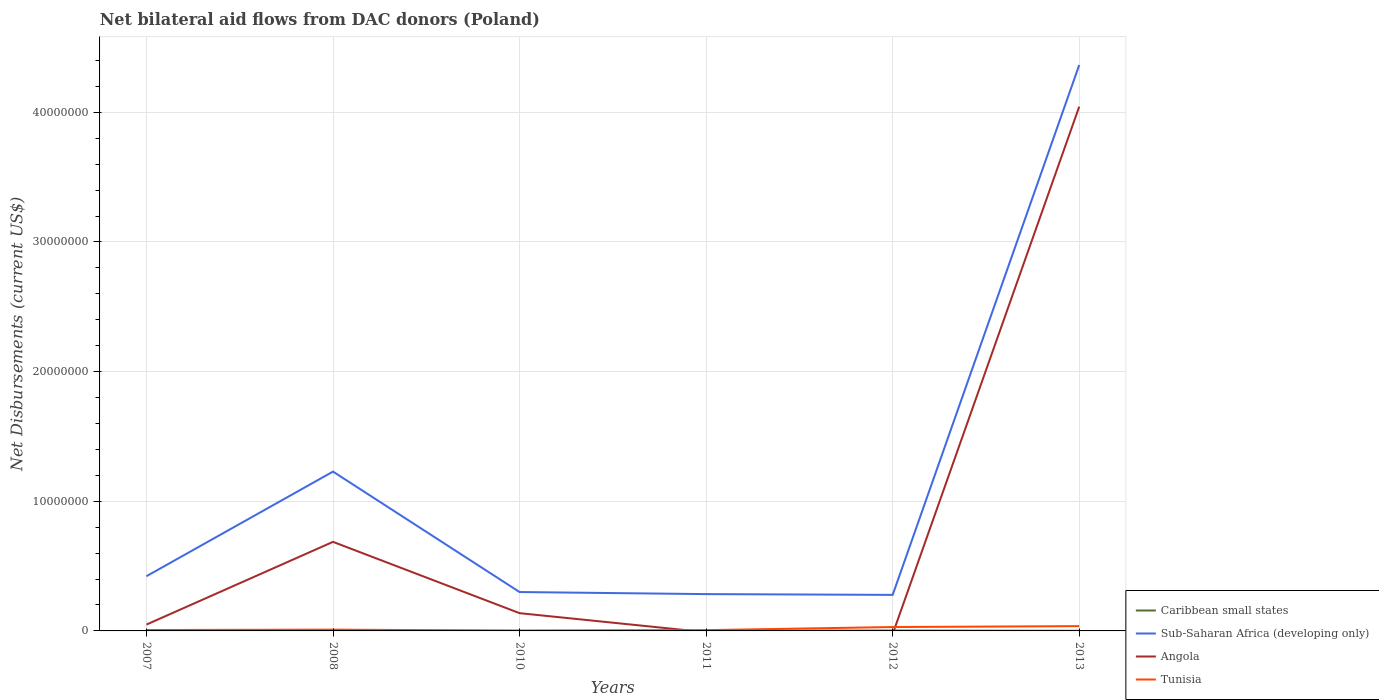Does the line corresponding to Caribbean small states intersect with the line corresponding to Sub-Saharan Africa (developing only)?
Your response must be concise. No. Is the number of lines equal to the number of legend labels?
Provide a short and direct response. No. What is the difference between the highest and the second highest net bilateral aid flows in Angola?
Ensure brevity in your answer.  4.04e+07. Is the net bilateral aid flows in Angola strictly greater than the net bilateral aid flows in Tunisia over the years?
Offer a terse response. No. How many lines are there?
Your response must be concise. 4. Are the values on the major ticks of Y-axis written in scientific E-notation?
Provide a succinct answer. No. Does the graph contain any zero values?
Give a very brief answer. Yes. Does the graph contain grids?
Make the answer very short. Yes. How are the legend labels stacked?
Ensure brevity in your answer.  Vertical. What is the title of the graph?
Offer a very short reply. Net bilateral aid flows from DAC donors (Poland). Does "Japan" appear as one of the legend labels in the graph?
Your answer should be compact. No. What is the label or title of the Y-axis?
Offer a terse response. Net Disbursements (current US$). What is the Net Disbursements (current US$) in Caribbean small states in 2007?
Your response must be concise. 7.00e+04. What is the Net Disbursements (current US$) in Sub-Saharan Africa (developing only) in 2007?
Make the answer very short. 4.22e+06. What is the Net Disbursements (current US$) in Angola in 2007?
Ensure brevity in your answer.  4.90e+05. What is the Net Disbursements (current US$) in Tunisia in 2007?
Your response must be concise. 7.00e+04. What is the Net Disbursements (current US$) in Caribbean small states in 2008?
Keep it short and to the point. 3.00e+04. What is the Net Disbursements (current US$) of Sub-Saharan Africa (developing only) in 2008?
Provide a succinct answer. 1.23e+07. What is the Net Disbursements (current US$) of Angola in 2008?
Give a very brief answer. 6.87e+06. What is the Net Disbursements (current US$) of Caribbean small states in 2010?
Keep it short and to the point. 10000. What is the Net Disbursements (current US$) in Sub-Saharan Africa (developing only) in 2010?
Your answer should be compact. 3.00e+06. What is the Net Disbursements (current US$) in Angola in 2010?
Make the answer very short. 1.37e+06. What is the Net Disbursements (current US$) in Caribbean small states in 2011?
Your response must be concise. 2.00e+04. What is the Net Disbursements (current US$) in Sub-Saharan Africa (developing only) in 2011?
Provide a succinct answer. 2.84e+06. What is the Net Disbursements (current US$) of Tunisia in 2011?
Your answer should be very brief. 6.00e+04. What is the Net Disbursements (current US$) in Caribbean small states in 2012?
Your answer should be compact. 3.00e+04. What is the Net Disbursements (current US$) of Sub-Saharan Africa (developing only) in 2012?
Your answer should be very brief. 2.78e+06. What is the Net Disbursements (current US$) of Sub-Saharan Africa (developing only) in 2013?
Ensure brevity in your answer.  4.36e+07. What is the Net Disbursements (current US$) of Angola in 2013?
Keep it short and to the point. 4.04e+07. What is the Net Disbursements (current US$) of Tunisia in 2013?
Ensure brevity in your answer.  3.70e+05. Across all years, what is the maximum Net Disbursements (current US$) in Caribbean small states?
Offer a very short reply. 7.00e+04. Across all years, what is the maximum Net Disbursements (current US$) of Sub-Saharan Africa (developing only)?
Your answer should be very brief. 4.36e+07. Across all years, what is the maximum Net Disbursements (current US$) of Angola?
Give a very brief answer. 4.04e+07. Across all years, what is the maximum Net Disbursements (current US$) in Tunisia?
Your response must be concise. 3.70e+05. Across all years, what is the minimum Net Disbursements (current US$) in Caribbean small states?
Your response must be concise. 10000. Across all years, what is the minimum Net Disbursements (current US$) of Sub-Saharan Africa (developing only)?
Ensure brevity in your answer.  2.78e+06. Across all years, what is the minimum Net Disbursements (current US$) of Angola?
Your answer should be very brief. 0. What is the total Net Disbursements (current US$) of Caribbean small states in the graph?
Provide a short and direct response. 1.70e+05. What is the total Net Disbursements (current US$) in Sub-Saharan Africa (developing only) in the graph?
Keep it short and to the point. 6.88e+07. What is the total Net Disbursements (current US$) of Angola in the graph?
Make the answer very short. 4.92e+07. What is the total Net Disbursements (current US$) in Tunisia in the graph?
Offer a very short reply. 9.20e+05. What is the difference between the Net Disbursements (current US$) of Caribbean small states in 2007 and that in 2008?
Your response must be concise. 4.00e+04. What is the difference between the Net Disbursements (current US$) in Sub-Saharan Africa (developing only) in 2007 and that in 2008?
Make the answer very short. -8.07e+06. What is the difference between the Net Disbursements (current US$) in Angola in 2007 and that in 2008?
Offer a very short reply. -6.38e+06. What is the difference between the Net Disbursements (current US$) of Tunisia in 2007 and that in 2008?
Give a very brief answer. -3.00e+04. What is the difference between the Net Disbursements (current US$) in Sub-Saharan Africa (developing only) in 2007 and that in 2010?
Offer a terse response. 1.22e+06. What is the difference between the Net Disbursements (current US$) in Angola in 2007 and that in 2010?
Your answer should be very brief. -8.80e+05. What is the difference between the Net Disbursements (current US$) in Sub-Saharan Africa (developing only) in 2007 and that in 2011?
Give a very brief answer. 1.38e+06. What is the difference between the Net Disbursements (current US$) in Caribbean small states in 2007 and that in 2012?
Offer a terse response. 4.00e+04. What is the difference between the Net Disbursements (current US$) of Sub-Saharan Africa (developing only) in 2007 and that in 2012?
Your response must be concise. 1.44e+06. What is the difference between the Net Disbursements (current US$) in Sub-Saharan Africa (developing only) in 2007 and that in 2013?
Your answer should be compact. -3.94e+07. What is the difference between the Net Disbursements (current US$) of Angola in 2007 and that in 2013?
Your response must be concise. -4.00e+07. What is the difference between the Net Disbursements (current US$) in Sub-Saharan Africa (developing only) in 2008 and that in 2010?
Make the answer very short. 9.29e+06. What is the difference between the Net Disbursements (current US$) in Angola in 2008 and that in 2010?
Keep it short and to the point. 5.50e+06. What is the difference between the Net Disbursements (current US$) of Caribbean small states in 2008 and that in 2011?
Provide a short and direct response. 10000. What is the difference between the Net Disbursements (current US$) in Sub-Saharan Africa (developing only) in 2008 and that in 2011?
Keep it short and to the point. 9.45e+06. What is the difference between the Net Disbursements (current US$) in Caribbean small states in 2008 and that in 2012?
Ensure brevity in your answer.  0. What is the difference between the Net Disbursements (current US$) in Sub-Saharan Africa (developing only) in 2008 and that in 2012?
Ensure brevity in your answer.  9.51e+06. What is the difference between the Net Disbursements (current US$) in Caribbean small states in 2008 and that in 2013?
Offer a very short reply. 2.00e+04. What is the difference between the Net Disbursements (current US$) of Sub-Saharan Africa (developing only) in 2008 and that in 2013?
Provide a short and direct response. -3.14e+07. What is the difference between the Net Disbursements (current US$) in Angola in 2008 and that in 2013?
Make the answer very short. -3.36e+07. What is the difference between the Net Disbursements (current US$) in Tunisia in 2008 and that in 2013?
Make the answer very short. -2.70e+05. What is the difference between the Net Disbursements (current US$) of Caribbean small states in 2010 and that in 2011?
Give a very brief answer. -10000. What is the difference between the Net Disbursements (current US$) in Sub-Saharan Africa (developing only) in 2010 and that in 2011?
Offer a terse response. 1.60e+05. What is the difference between the Net Disbursements (current US$) in Tunisia in 2010 and that in 2011?
Offer a very short reply. -4.00e+04. What is the difference between the Net Disbursements (current US$) of Tunisia in 2010 and that in 2012?
Your answer should be very brief. -2.80e+05. What is the difference between the Net Disbursements (current US$) of Sub-Saharan Africa (developing only) in 2010 and that in 2013?
Offer a very short reply. -4.06e+07. What is the difference between the Net Disbursements (current US$) of Angola in 2010 and that in 2013?
Ensure brevity in your answer.  -3.91e+07. What is the difference between the Net Disbursements (current US$) in Tunisia in 2010 and that in 2013?
Provide a short and direct response. -3.50e+05. What is the difference between the Net Disbursements (current US$) of Caribbean small states in 2011 and that in 2012?
Your response must be concise. -10000. What is the difference between the Net Disbursements (current US$) in Sub-Saharan Africa (developing only) in 2011 and that in 2012?
Provide a short and direct response. 6.00e+04. What is the difference between the Net Disbursements (current US$) in Caribbean small states in 2011 and that in 2013?
Make the answer very short. 10000. What is the difference between the Net Disbursements (current US$) of Sub-Saharan Africa (developing only) in 2011 and that in 2013?
Your response must be concise. -4.08e+07. What is the difference between the Net Disbursements (current US$) of Tunisia in 2011 and that in 2013?
Your answer should be compact. -3.10e+05. What is the difference between the Net Disbursements (current US$) of Sub-Saharan Africa (developing only) in 2012 and that in 2013?
Provide a succinct answer. -4.09e+07. What is the difference between the Net Disbursements (current US$) in Tunisia in 2012 and that in 2013?
Offer a very short reply. -7.00e+04. What is the difference between the Net Disbursements (current US$) in Caribbean small states in 2007 and the Net Disbursements (current US$) in Sub-Saharan Africa (developing only) in 2008?
Provide a succinct answer. -1.22e+07. What is the difference between the Net Disbursements (current US$) of Caribbean small states in 2007 and the Net Disbursements (current US$) of Angola in 2008?
Keep it short and to the point. -6.80e+06. What is the difference between the Net Disbursements (current US$) of Caribbean small states in 2007 and the Net Disbursements (current US$) of Tunisia in 2008?
Your answer should be compact. -3.00e+04. What is the difference between the Net Disbursements (current US$) of Sub-Saharan Africa (developing only) in 2007 and the Net Disbursements (current US$) of Angola in 2008?
Make the answer very short. -2.65e+06. What is the difference between the Net Disbursements (current US$) of Sub-Saharan Africa (developing only) in 2007 and the Net Disbursements (current US$) of Tunisia in 2008?
Keep it short and to the point. 4.12e+06. What is the difference between the Net Disbursements (current US$) in Caribbean small states in 2007 and the Net Disbursements (current US$) in Sub-Saharan Africa (developing only) in 2010?
Provide a succinct answer. -2.93e+06. What is the difference between the Net Disbursements (current US$) in Caribbean small states in 2007 and the Net Disbursements (current US$) in Angola in 2010?
Your answer should be very brief. -1.30e+06. What is the difference between the Net Disbursements (current US$) in Sub-Saharan Africa (developing only) in 2007 and the Net Disbursements (current US$) in Angola in 2010?
Your answer should be compact. 2.85e+06. What is the difference between the Net Disbursements (current US$) of Sub-Saharan Africa (developing only) in 2007 and the Net Disbursements (current US$) of Tunisia in 2010?
Your answer should be very brief. 4.20e+06. What is the difference between the Net Disbursements (current US$) in Caribbean small states in 2007 and the Net Disbursements (current US$) in Sub-Saharan Africa (developing only) in 2011?
Your answer should be very brief. -2.77e+06. What is the difference between the Net Disbursements (current US$) in Sub-Saharan Africa (developing only) in 2007 and the Net Disbursements (current US$) in Tunisia in 2011?
Ensure brevity in your answer.  4.16e+06. What is the difference between the Net Disbursements (current US$) in Caribbean small states in 2007 and the Net Disbursements (current US$) in Sub-Saharan Africa (developing only) in 2012?
Provide a succinct answer. -2.71e+06. What is the difference between the Net Disbursements (current US$) in Sub-Saharan Africa (developing only) in 2007 and the Net Disbursements (current US$) in Tunisia in 2012?
Offer a terse response. 3.92e+06. What is the difference between the Net Disbursements (current US$) in Caribbean small states in 2007 and the Net Disbursements (current US$) in Sub-Saharan Africa (developing only) in 2013?
Offer a very short reply. -4.36e+07. What is the difference between the Net Disbursements (current US$) in Caribbean small states in 2007 and the Net Disbursements (current US$) in Angola in 2013?
Provide a succinct answer. -4.04e+07. What is the difference between the Net Disbursements (current US$) in Sub-Saharan Africa (developing only) in 2007 and the Net Disbursements (current US$) in Angola in 2013?
Provide a short and direct response. -3.62e+07. What is the difference between the Net Disbursements (current US$) in Sub-Saharan Africa (developing only) in 2007 and the Net Disbursements (current US$) in Tunisia in 2013?
Your answer should be very brief. 3.85e+06. What is the difference between the Net Disbursements (current US$) of Caribbean small states in 2008 and the Net Disbursements (current US$) of Sub-Saharan Africa (developing only) in 2010?
Keep it short and to the point. -2.97e+06. What is the difference between the Net Disbursements (current US$) of Caribbean small states in 2008 and the Net Disbursements (current US$) of Angola in 2010?
Offer a very short reply. -1.34e+06. What is the difference between the Net Disbursements (current US$) in Caribbean small states in 2008 and the Net Disbursements (current US$) in Tunisia in 2010?
Give a very brief answer. 10000. What is the difference between the Net Disbursements (current US$) of Sub-Saharan Africa (developing only) in 2008 and the Net Disbursements (current US$) of Angola in 2010?
Offer a very short reply. 1.09e+07. What is the difference between the Net Disbursements (current US$) in Sub-Saharan Africa (developing only) in 2008 and the Net Disbursements (current US$) in Tunisia in 2010?
Your response must be concise. 1.23e+07. What is the difference between the Net Disbursements (current US$) in Angola in 2008 and the Net Disbursements (current US$) in Tunisia in 2010?
Your response must be concise. 6.85e+06. What is the difference between the Net Disbursements (current US$) in Caribbean small states in 2008 and the Net Disbursements (current US$) in Sub-Saharan Africa (developing only) in 2011?
Provide a succinct answer. -2.81e+06. What is the difference between the Net Disbursements (current US$) in Sub-Saharan Africa (developing only) in 2008 and the Net Disbursements (current US$) in Tunisia in 2011?
Ensure brevity in your answer.  1.22e+07. What is the difference between the Net Disbursements (current US$) in Angola in 2008 and the Net Disbursements (current US$) in Tunisia in 2011?
Ensure brevity in your answer.  6.81e+06. What is the difference between the Net Disbursements (current US$) in Caribbean small states in 2008 and the Net Disbursements (current US$) in Sub-Saharan Africa (developing only) in 2012?
Provide a short and direct response. -2.75e+06. What is the difference between the Net Disbursements (current US$) of Caribbean small states in 2008 and the Net Disbursements (current US$) of Tunisia in 2012?
Give a very brief answer. -2.70e+05. What is the difference between the Net Disbursements (current US$) in Sub-Saharan Africa (developing only) in 2008 and the Net Disbursements (current US$) in Tunisia in 2012?
Your response must be concise. 1.20e+07. What is the difference between the Net Disbursements (current US$) in Angola in 2008 and the Net Disbursements (current US$) in Tunisia in 2012?
Make the answer very short. 6.57e+06. What is the difference between the Net Disbursements (current US$) in Caribbean small states in 2008 and the Net Disbursements (current US$) in Sub-Saharan Africa (developing only) in 2013?
Keep it short and to the point. -4.36e+07. What is the difference between the Net Disbursements (current US$) in Caribbean small states in 2008 and the Net Disbursements (current US$) in Angola in 2013?
Your answer should be compact. -4.04e+07. What is the difference between the Net Disbursements (current US$) in Sub-Saharan Africa (developing only) in 2008 and the Net Disbursements (current US$) in Angola in 2013?
Provide a short and direct response. -2.82e+07. What is the difference between the Net Disbursements (current US$) of Sub-Saharan Africa (developing only) in 2008 and the Net Disbursements (current US$) of Tunisia in 2013?
Give a very brief answer. 1.19e+07. What is the difference between the Net Disbursements (current US$) of Angola in 2008 and the Net Disbursements (current US$) of Tunisia in 2013?
Give a very brief answer. 6.50e+06. What is the difference between the Net Disbursements (current US$) in Caribbean small states in 2010 and the Net Disbursements (current US$) in Sub-Saharan Africa (developing only) in 2011?
Your answer should be very brief. -2.83e+06. What is the difference between the Net Disbursements (current US$) of Caribbean small states in 2010 and the Net Disbursements (current US$) of Tunisia in 2011?
Ensure brevity in your answer.  -5.00e+04. What is the difference between the Net Disbursements (current US$) of Sub-Saharan Africa (developing only) in 2010 and the Net Disbursements (current US$) of Tunisia in 2011?
Provide a short and direct response. 2.94e+06. What is the difference between the Net Disbursements (current US$) of Angola in 2010 and the Net Disbursements (current US$) of Tunisia in 2011?
Keep it short and to the point. 1.31e+06. What is the difference between the Net Disbursements (current US$) of Caribbean small states in 2010 and the Net Disbursements (current US$) of Sub-Saharan Africa (developing only) in 2012?
Provide a succinct answer. -2.77e+06. What is the difference between the Net Disbursements (current US$) in Sub-Saharan Africa (developing only) in 2010 and the Net Disbursements (current US$) in Tunisia in 2012?
Provide a succinct answer. 2.70e+06. What is the difference between the Net Disbursements (current US$) of Angola in 2010 and the Net Disbursements (current US$) of Tunisia in 2012?
Provide a succinct answer. 1.07e+06. What is the difference between the Net Disbursements (current US$) in Caribbean small states in 2010 and the Net Disbursements (current US$) in Sub-Saharan Africa (developing only) in 2013?
Make the answer very short. -4.36e+07. What is the difference between the Net Disbursements (current US$) of Caribbean small states in 2010 and the Net Disbursements (current US$) of Angola in 2013?
Your response must be concise. -4.04e+07. What is the difference between the Net Disbursements (current US$) of Caribbean small states in 2010 and the Net Disbursements (current US$) of Tunisia in 2013?
Ensure brevity in your answer.  -3.60e+05. What is the difference between the Net Disbursements (current US$) in Sub-Saharan Africa (developing only) in 2010 and the Net Disbursements (current US$) in Angola in 2013?
Provide a short and direct response. -3.74e+07. What is the difference between the Net Disbursements (current US$) in Sub-Saharan Africa (developing only) in 2010 and the Net Disbursements (current US$) in Tunisia in 2013?
Provide a succinct answer. 2.63e+06. What is the difference between the Net Disbursements (current US$) of Angola in 2010 and the Net Disbursements (current US$) of Tunisia in 2013?
Ensure brevity in your answer.  1.00e+06. What is the difference between the Net Disbursements (current US$) in Caribbean small states in 2011 and the Net Disbursements (current US$) in Sub-Saharan Africa (developing only) in 2012?
Ensure brevity in your answer.  -2.76e+06. What is the difference between the Net Disbursements (current US$) in Caribbean small states in 2011 and the Net Disbursements (current US$) in Tunisia in 2012?
Make the answer very short. -2.80e+05. What is the difference between the Net Disbursements (current US$) of Sub-Saharan Africa (developing only) in 2011 and the Net Disbursements (current US$) of Tunisia in 2012?
Your answer should be very brief. 2.54e+06. What is the difference between the Net Disbursements (current US$) of Caribbean small states in 2011 and the Net Disbursements (current US$) of Sub-Saharan Africa (developing only) in 2013?
Make the answer very short. -4.36e+07. What is the difference between the Net Disbursements (current US$) in Caribbean small states in 2011 and the Net Disbursements (current US$) in Angola in 2013?
Offer a terse response. -4.04e+07. What is the difference between the Net Disbursements (current US$) of Caribbean small states in 2011 and the Net Disbursements (current US$) of Tunisia in 2013?
Offer a terse response. -3.50e+05. What is the difference between the Net Disbursements (current US$) in Sub-Saharan Africa (developing only) in 2011 and the Net Disbursements (current US$) in Angola in 2013?
Your answer should be compact. -3.76e+07. What is the difference between the Net Disbursements (current US$) of Sub-Saharan Africa (developing only) in 2011 and the Net Disbursements (current US$) of Tunisia in 2013?
Give a very brief answer. 2.47e+06. What is the difference between the Net Disbursements (current US$) of Caribbean small states in 2012 and the Net Disbursements (current US$) of Sub-Saharan Africa (developing only) in 2013?
Keep it short and to the point. -4.36e+07. What is the difference between the Net Disbursements (current US$) in Caribbean small states in 2012 and the Net Disbursements (current US$) in Angola in 2013?
Provide a short and direct response. -4.04e+07. What is the difference between the Net Disbursements (current US$) of Caribbean small states in 2012 and the Net Disbursements (current US$) of Tunisia in 2013?
Your answer should be very brief. -3.40e+05. What is the difference between the Net Disbursements (current US$) of Sub-Saharan Africa (developing only) in 2012 and the Net Disbursements (current US$) of Angola in 2013?
Provide a succinct answer. -3.77e+07. What is the difference between the Net Disbursements (current US$) in Sub-Saharan Africa (developing only) in 2012 and the Net Disbursements (current US$) in Tunisia in 2013?
Your response must be concise. 2.41e+06. What is the average Net Disbursements (current US$) in Caribbean small states per year?
Your answer should be very brief. 2.83e+04. What is the average Net Disbursements (current US$) of Sub-Saharan Africa (developing only) per year?
Ensure brevity in your answer.  1.15e+07. What is the average Net Disbursements (current US$) in Angola per year?
Make the answer very short. 8.20e+06. What is the average Net Disbursements (current US$) in Tunisia per year?
Provide a short and direct response. 1.53e+05. In the year 2007, what is the difference between the Net Disbursements (current US$) in Caribbean small states and Net Disbursements (current US$) in Sub-Saharan Africa (developing only)?
Make the answer very short. -4.15e+06. In the year 2007, what is the difference between the Net Disbursements (current US$) of Caribbean small states and Net Disbursements (current US$) of Angola?
Ensure brevity in your answer.  -4.20e+05. In the year 2007, what is the difference between the Net Disbursements (current US$) in Sub-Saharan Africa (developing only) and Net Disbursements (current US$) in Angola?
Give a very brief answer. 3.73e+06. In the year 2007, what is the difference between the Net Disbursements (current US$) in Sub-Saharan Africa (developing only) and Net Disbursements (current US$) in Tunisia?
Offer a terse response. 4.15e+06. In the year 2007, what is the difference between the Net Disbursements (current US$) of Angola and Net Disbursements (current US$) of Tunisia?
Provide a short and direct response. 4.20e+05. In the year 2008, what is the difference between the Net Disbursements (current US$) of Caribbean small states and Net Disbursements (current US$) of Sub-Saharan Africa (developing only)?
Your response must be concise. -1.23e+07. In the year 2008, what is the difference between the Net Disbursements (current US$) in Caribbean small states and Net Disbursements (current US$) in Angola?
Keep it short and to the point. -6.84e+06. In the year 2008, what is the difference between the Net Disbursements (current US$) of Sub-Saharan Africa (developing only) and Net Disbursements (current US$) of Angola?
Provide a short and direct response. 5.42e+06. In the year 2008, what is the difference between the Net Disbursements (current US$) of Sub-Saharan Africa (developing only) and Net Disbursements (current US$) of Tunisia?
Make the answer very short. 1.22e+07. In the year 2008, what is the difference between the Net Disbursements (current US$) of Angola and Net Disbursements (current US$) of Tunisia?
Give a very brief answer. 6.77e+06. In the year 2010, what is the difference between the Net Disbursements (current US$) in Caribbean small states and Net Disbursements (current US$) in Sub-Saharan Africa (developing only)?
Give a very brief answer. -2.99e+06. In the year 2010, what is the difference between the Net Disbursements (current US$) of Caribbean small states and Net Disbursements (current US$) of Angola?
Give a very brief answer. -1.36e+06. In the year 2010, what is the difference between the Net Disbursements (current US$) in Sub-Saharan Africa (developing only) and Net Disbursements (current US$) in Angola?
Your answer should be very brief. 1.63e+06. In the year 2010, what is the difference between the Net Disbursements (current US$) in Sub-Saharan Africa (developing only) and Net Disbursements (current US$) in Tunisia?
Your answer should be compact. 2.98e+06. In the year 2010, what is the difference between the Net Disbursements (current US$) in Angola and Net Disbursements (current US$) in Tunisia?
Offer a very short reply. 1.35e+06. In the year 2011, what is the difference between the Net Disbursements (current US$) in Caribbean small states and Net Disbursements (current US$) in Sub-Saharan Africa (developing only)?
Provide a succinct answer. -2.82e+06. In the year 2011, what is the difference between the Net Disbursements (current US$) of Caribbean small states and Net Disbursements (current US$) of Tunisia?
Provide a short and direct response. -4.00e+04. In the year 2011, what is the difference between the Net Disbursements (current US$) in Sub-Saharan Africa (developing only) and Net Disbursements (current US$) in Tunisia?
Your response must be concise. 2.78e+06. In the year 2012, what is the difference between the Net Disbursements (current US$) of Caribbean small states and Net Disbursements (current US$) of Sub-Saharan Africa (developing only)?
Keep it short and to the point. -2.75e+06. In the year 2012, what is the difference between the Net Disbursements (current US$) in Sub-Saharan Africa (developing only) and Net Disbursements (current US$) in Tunisia?
Give a very brief answer. 2.48e+06. In the year 2013, what is the difference between the Net Disbursements (current US$) in Caribbean small states and Net Disbursements (current US$) in Sub-Saharan Africa (developing only)?
Offer a very short reply. -4.36e+07. In the year 2013, what is the difference between the Net Disbursements (current US$) of Caribbean small states and Net Disbursements (current US$) of Angola?
Offer a very short reply. -4.04e+07. In the year 2013, what is the difference between the Net Disbursements (current US$) in Caribbean small states and Net Disbursements (current US$) in Tunisia?
Your answer should be compact. -3.60e+05. In the year 2013, what is the difference between the Net Disbursements (current US$) of Sub-Saharan Africa (developing only) and Net Disbursements (current US$) of Angola?
Provide a succinct answer. 3.21e+06. In the year 2013, what is the difference between the Net Disbursements (current US$) of Sub-Saharan Africa (developing only) and Net Disbursements (current US$) of Tunisia?
Your response must be concise. 4.33e+07. In the year 2013, what is the difference between the Net Disbursements (current US$) of Angola and Net Disbursements (current US$) of Tunisia?
Keep it short and to the point. 4.01e+07. What is the ratio of the Net Disbursements (current US$) in Caribbean small states in 2007 to that in 2008?
Make the answer very short. 2.33. What is the ratio of the Net Disbursements (current US$) in Sub-Saharan Africa (developing only) in 2007 to that in 2008?
Offer a terse response. 0.34. What is the ratio of the Net Disbursements (current US$) of Angola in 2007 to that in 2008?
Offer a terse response. 0.07. What is the ratio of the Net Disbursements (current US$) of Sub-Saharan Africa (developing only) in 2007 to that in 2010?
Offer a terse response. 1.41. What is the ratio of the Net Disbursements (current US$) of Angola in 2007 to that in 2010?
Your answer should be very brief. 0.36. What is the ratio of the Net Disbursements (current US$) in Tunisia in 2007 to that in 2010?
Make the answer very short. 3.5. What is the ratio of the Net Disbursements (current US$) in Sub-Saharan Africa (developing only) in 2007 to that in 2011?
Offer a terse response. 1.49. What is the ratio of the Net Disbursements (current US$) of Tunisia in 2007 to that in 2011?
Your response must be concise. 1.17. What is the ratio of the Net Disbursements (current US$) of Caribbean small states in 2007 to that in 2012?
Give a very brief answer. 2.33. What is the ratio of the Net Disbursements (current US$) of Sub-Saharan Africa (developing only) in 2007 to that in 2012?
Offer a very short reply. 1.52. What is the ratio of the Net Disbursements (current US$) of Tunisia in 2007 to that in 2012?
Provide a short and direct response. 0.23. What is the ratio of the Net Disbursements (current US$) of Caribbean small states in 2007 to that in 2013?
Provide a succinct answer. 7. What is the ratio of the Net Disbursements (current US$) of Sub-Saharan Africa (developing only) in 2007 to that in 2013?
Provide a short and direct response. 0.1. What is the ratio of the Net Disbursements (current US$) in Angola in 2007 to that in 2013?
Ensure brevity in your answer.  0.01. What is the ratio of the Net Disbursements (current US$) of Tunisia in 2007 to that in 2013?
Make the answer very short. 0.19. What is the ratio of the Net Disbursements (current US$) of Caribbean small states in 2008 to that in 2010?
Keep it short and to the point. 3. What is the ratio of the Net Disbursements (current US$) in Sub-Saharan Africa (developing only) in 2008 to that in 2010?
Provide a short and direct response. 4.1. What is the ratio of the Net Disbursements (current US$) in Angola in 2008 to that in 2010?
Give a very brief answer. 5.01. What is the ratio of the Net Disbursements (current US$) of Tunisia in 2008 to that in 2010?
Give a very brief answer. 5. What is the ratio of the Net Disbursements (current US$) in Caribbean small states in 2008 to that in 2011?
Provide a short and direct response. 1.5. What is the ratio of the Net Disbursements (current US$) of Sub-Saharan Africa (developing only) in 2008 to that in 2011?
Your answer should be very brief. 4.33. What is the ratio of the Net Disbursements (current US$) in Caribbean small states in 2008 to that in 2012?
Provide a short and direct response. 1. What is the ratio of the Net Disbursements (current US$) in Sub-Saharan Africa (developing only) in 2008 to that in 2012?
Your answer should be compact. 4.42. What is the ratio of the Net Disbursements (current US$) of Caribbean small states in 2008 to that in 2013?
Offer a terse response. 3. What is the ratio of the Net Disbursements (current US$) of Sub-Saharan Africa (developing only) in 2008 to that in 2013?
Make the answer very short. 0.28. What is the ratio of the Net Disbursements (current US$) in Angola in 2008 to that in 2013?
Offer a terse response. 0.17. What is the ratio of the Net Disbursements (current US$) of Tunisia in 2008 to that in 2013?
Your answer should be compact. 0.27. What is the ratio of the Net Disbursements (current US$) in Sub-Saharan Africa (developing only) in 2010 to that in 2011?
Make the answer very short. 1.06. What is the ratio of the Net Disbursements (current US$) in Tunisia in 2010 to that in 2011?
Offer a very short reply. 0.33. What is the ratio of the Net Disbursements (current US$) in Sub-Saharan Africa (developing only) in 2010 to that in 2012?
Ensure brevity in your answer.  1.08. What is the ratio of the Net Disbursements (current US$) in Tunisia in 2010 to that in 2012?
Your answer should be compact. 0.07. What is the ratio of the Net Disbursements (current US$) in Sub-Saharan Africa (developing only) in 2010 to that in 2013?
Your response must be concise. 0.07. What is the ratio of the Net Disbursements (current US$) of Angola in 2010 to that in 2013?
Your answer should be compact. 0.03. What is the ratio of the Net Disbursements (current US$) in Tunisia in 2010 to that in 2013?
Make the answer very short. 0.05. What is the ratio of the Net Disbursements (current US$) of Caribbean small states in 2011 to that in 2012?
Offer a terse response. 0.67. What is the ratio of the Net Disbursements (current US$) in Sub-Saharan Africa (developing only) in 2011 to that in 2012?
Provide a succinct answer. 1.02. What is the ratio of the Net Disbursements (current US$) in Caribbean small states in 2011 to that in 2013?
Your answer should be very brief. 2. What is the ratio of the Net Disbursements (current US$) in Sub-Saharan Africa (developing only) in 2011 to that in 2013?
Your answer should be compact. 0.07. What is the ratio of the Net Disbursements (current US$) in Tunisia in 2011 to that in 2013?
Provide a short and direct response. 0.16. What is the ratio of the Net Disbursements (current US$) of Caribbean small states in 2012 to that in 2013?
Make the answer very short. 3. What is the ratio of the Net Disbursements (current US$) of Sub-Saharan Africa (developing only) in 2012 to that in 2013?
Provide a short and direct response. 0.06. What is the ratio of the Net Disbursements (current US$) in Tunisia in 2012 to that in 2013?
Make the answer very short. 0.81. What is the difference between the highest and the second highest Net Disbursements (current US$) in Caribbean small states?
Keep it short and to the point. 4.00e+04. What is the difference between the highest and the second highest Net Disbursements (current US$) in Sub-Saharan Africa (developing only)?
Provide a short and direct response. 3.14e+07. What is the difference between the highest and the second highest Net Disbursements (current US$) of Angola?
Offer a terse response. 3.36e+07. What is the difference between the highest and the second highest Net Disbursements (current US$) of Tunisia?
Keep it short and to the point. 7.00e+04. What is the difference between the highest and the lowest Net Disbursements (current US$) of Sub-Saharan Africa (developing only)?
Provide a succinct answer. 4.09e+07. What is the difference between the highest and the lowest Net Disbursements (current US$) of Angola?
Keep it short and to the point. 4.04e+07. 